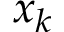<formula> <loc_0><loc_0><loc_500><loc_500>x _ { k }</formula> 